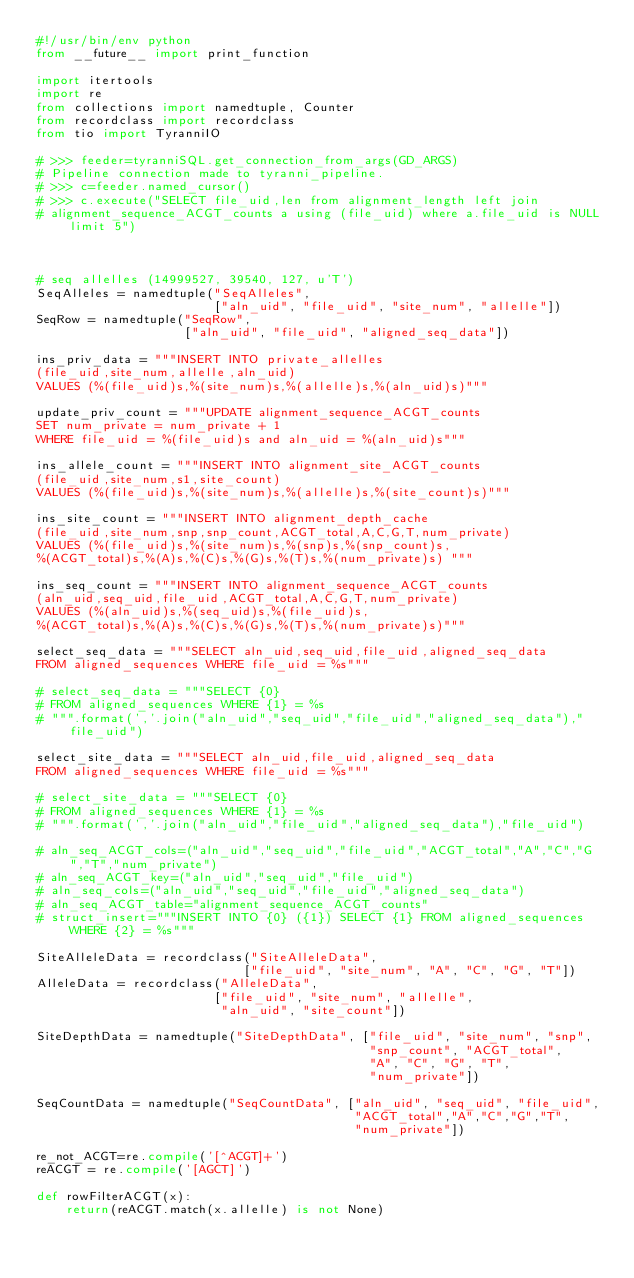Convert code to text. <code><loc_0><loc_0><loc_500><loc_500><_Python_>#!/usr/bin/env python
from __future__ import print_function

import itertools
import re
from collections import namedtuple, Counter
from recordclass import recordclass
from tio import TyranniIO

# >>> feeder=tyranniSQL.get_connection_from_args(GD_ARGS)
# Pipeline connection made to tyranni_pipeline.
# >>> c=feeder.named_cursor()
# >>> c.execute("SELECT file_uid,len from alignment_length left join 
# alignment_sequence_ACGT_counts a using (file_uid) where a.file_uid is NULL limit 5") 



# seq allelles (14999527, 39540, 127, u'T')
SeqAlleles = namedtuple("SeqAlleles",
                        ["aln_uid", "file_uid", "site_num", "allelle"])
SeqRow = namedtuple("SeqRow",
                    ["aln_uid", "file_uid", "aligned_seq_data"])

ins_priv_data = """INSERT INTO private_allelles
(file_uid,site_num,allelle,aln_uid)
VALUES (%(file_uid)s,%(site_num)s,%(allelle)s,%(aln_uid)s)"""

update_priv_count = """UPDATE alignment_sequence_ACGT_counts
SET num_private = num_private + 1
WHERE file_uid = %(file_uid)s and aln_uid = %(aln_uid)s"""

ins_allele_count = """INSERT INTO alignment_site_ACGT_counts
(file_uid,site_num,s1,site_count)
VALUES (%(file_uid)s,%(site_num)s,%(allelle)s,%(site_count)s)"""

ins_site_count = """INSERT INTO alignment_depth_cache
(file_uid,site_num,snp,snp_count,ACGT_total,A,C,G,T,num_private)
VALUES (%(file_uid)s,%(site_num)s,%(snp)s,%(snp_count)s,
%(ACGT_total)s,%(A)s,%(C)s,%(G)s,%(T)s,%(num_private)s) """

ins_seq_count = """INSERT INTO alignment_sequence_ACGT_counts
(aln_uid,seq_uid,file_uid,ACGT_total,A,C,G,T,num_private)
VALUES (%(aln_uid)s,%(seq_uid)s,%(file_uid)s,
%(ACGT_total)s,%(A)s,%(C)s,%(G)s,%(T)s,%(num_private)s)"""

select_seq_data = """SELECT aln_uid,seq_uid,file_uid,aligned_seq_data
FROM aligned_sequences WHERE file_uid = %s"""

# select_seq_data = """SELECT {0}
# FROM aligned_sequences WHERE {1} = %s
# """.format(','.join("aln_uid","seq_uid","file_uid","aligned_seq_data"),"file_uid")

select_site_data = """SELECT aln_uid,file_uid,aligned_seq_data
FROM aligned_sequences WHERE file_uid = %s"""

# select_site_data = """SELECT {0}
# FROM aligned_sequences WHERE {1} = %s
# """.format(','.join("aln_uid","file_uid","aligned_seq_data"),"file_uid")

# aln_seq_ACGT_cols=("aln_uid","seq_uid","file_uid","ACGT_total","A","C","G","T","num_private")
# aln_seq_ACGT_key=("aln_uid","seq_uid","file_uid")
# aln_seq_cols=("aln_uid","seq_uid","file_uid","aligned_seq_data")
# aln_seq_ACGT_table="alignment_sequence_ACGT_counts"
# struct_insert="""INSERT INTO {0} ({1}) SELECT {1} FROM aligned_sequences WHERE {2} = %s"""

SiteAlleleData = recordclass("SiteAlleleData",
                            ["file_uid", "site_num", "A", "C", "G", "T"])
AlleleData = recordclass("AlleleData",
                        ["file_uid", "site_num", "allelle",
                         "aln_uid", "site_count"])

SiteDepthData = namedtuple("SiteDepthData", ["file_uid", "site_num", "snp",
                                             "snp_count", "ACGT_total",
                                             "A", "C", "G", "T",
                                             "num_private"])

SeqCountData = namedtuple("SeqCountData", ["aln_uid", "seq_uid", "file_uid",
                                           "ACGT_total","A","C","G","T",
                                           "num_private"])

re_not_ACGT=re.compile('[^ACGT]+')
reACGT = re.compile('[AGCT]')

def rowFilterACGT(x):
    return(reACGT.match(x.allelle) is not None)
</code> 